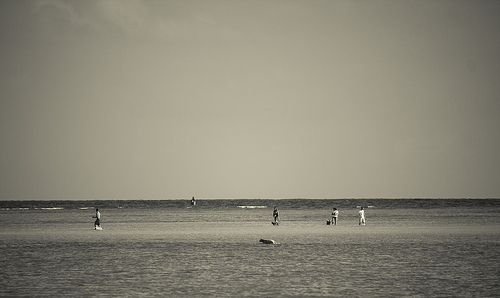Person walking a dog on the beach. An endearing scene of companionship, a person walking a dog would be a dynamic image with both figures positioned in mid-movement, showcasing the bond between human and pet. 